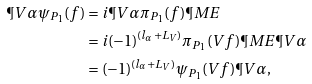Convert formula to latex. <formula><loc_0><loc_0><loc_500><loc_500>\P V { \alpha } \psi _ { P _ { 1 } } ( f ) & = i \P V { \alpha } \pi _ { P _ { 1 } } ( f ) \P M E \\ & = i ( - 1 ) ^ { ( l _ { \alpha } + L _ { V } ) } \pi _ { P _ { 1 } } ( V f ) \P M E \P V { \alpha } \\ & = ( - 1 ) ^ { ( l _ { \alpha } + L _ { V } ) } \psi _ { P _ { 1 } } ( V f ) \P V { \alpha } ,</formula> 